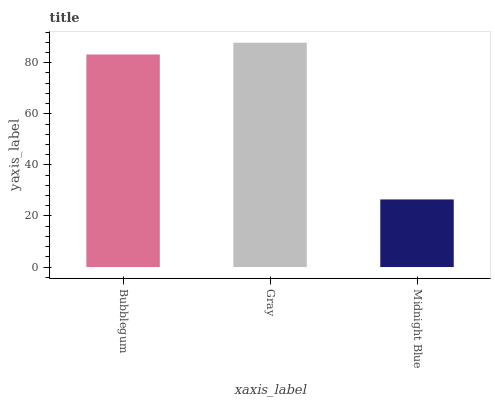Is Midnight Blue the minimum?
Answer yes or no. Yes. Is Gray the maximum?
Answer yes or no. Yes. Is Gray the minimum?
Answer yes or no. No. Is Midnight Blue the maximum?
Answer yes or no. No. Is Gray greater than Midnight Blue?
Answer yes or no. Yes. Is Midnight Blue less than Gray?
Answer yes or no. Yes. Is Midnight Blue greater than Gray?
Answer yes or no. No. Is Gray less than Midnight Blue?
Answer yes or no. No. Is Bubblegum the high median?
Answer yes or no. Yes. Is Bubblegum the low median?
Answer yes or no. Yes. Is Gray the high median?
Answer yes or no. No. Is Midnight Blue the low median?
Answer yes or no. No. 